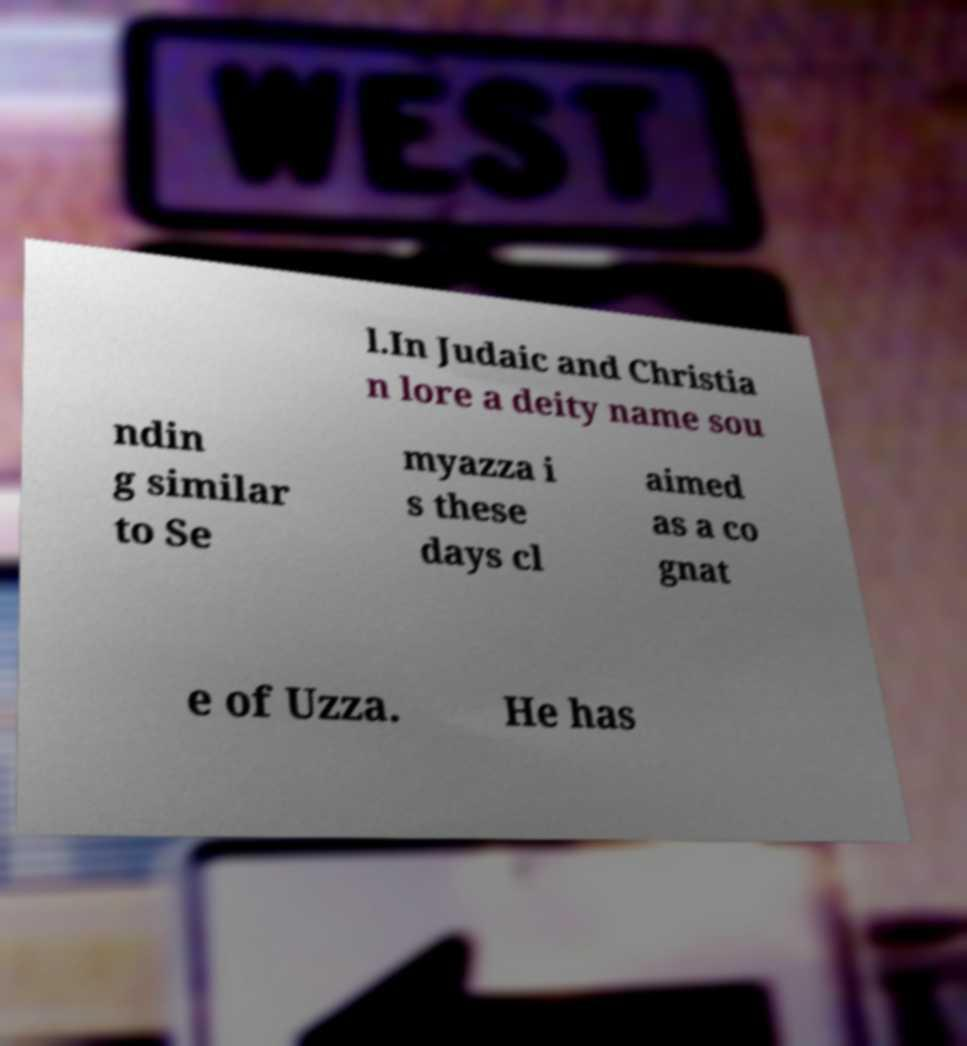Could you extract and type out the text from this image? l.In Judaic and Christia n lore a deity name sou ndin g similar to Se myazza i s these days cl aimed as a co gnat e of Uzza. He has 